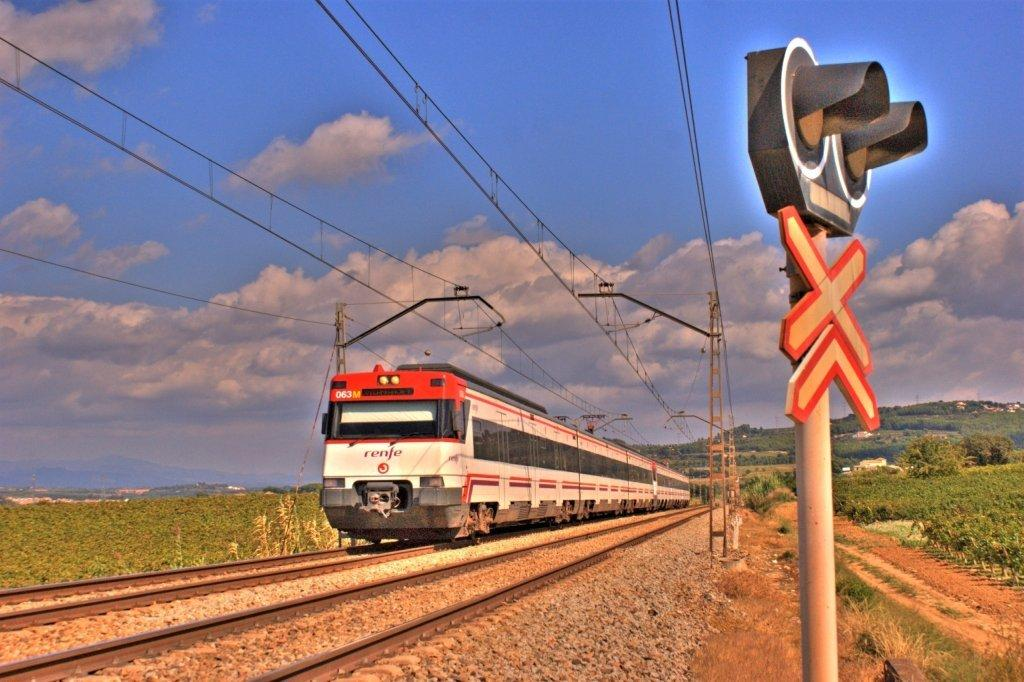What is the main subject of the image? The main subject of the image is a train on the tracks. What else can be seen in the image besides the train? There are electrical poles, plants, and a mountain visible in the image. How many women are visible in the image? There are no women present in the image. What type of rod is being used to control the train in the image? There is no rod visible in the image, and the train is not being controlled in the image. 